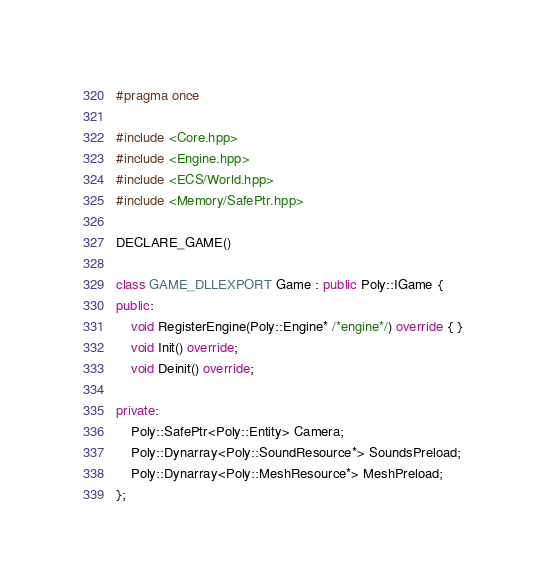<code> <loc_0><loc_0><loc_500><loc_500><_C++_>#pragma once

#include <Core.hpp>
#include <Engine.hpp>
#include <ECS/World.hpp>
#include <Memory/SafePtr.hpp>

DECLARE_GAME()

class GAME_DLLEXPORT Game : public Poly::IGame {
public:
	void RegisterEngine(Poly::Engine* /*engine*/) override { }
	void Init() override;
	void Deinit() override;

private:
	Poly::SafePtr<Poly::Entity> Camera;
	Poly::Dynarray<Poly::SoundResource*> SoundsPreload;
	Poly::Dynarray<Poly::MeshResource*> MeshPreload;
};
</code> 